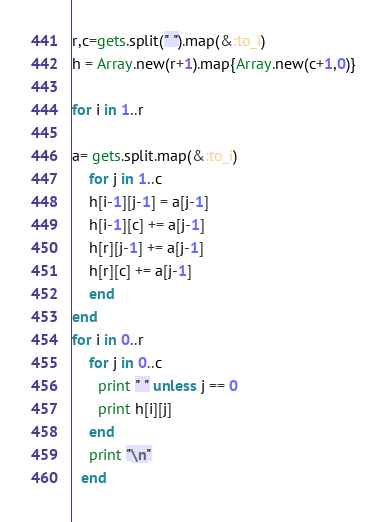Convert code to text. <code><loc_0><loc_0><loc_500><loc_500><_Ruby_>
r,c=gets.split(" ").map(&:to_i)
h = Array.new(r+1).map{Array.new(c+1,0)} 

for i in 1..r

a= gets.split.map(&:to_i)
    for j in 1..c
    h[i-1][j-1] = a[j-1]
    h[i-1][c] += a[j-1]
    h[r][j-1] += a[j-1]
    h[r][c] += a[j-1]
    end
end
for i in 0..r
    for j in 0..c
      print " " unless j == 0
      print h[i][j]
    end
    print "\n"
  end

</code> 